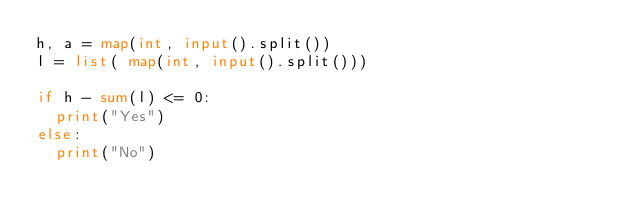<code> <loc_0><loc_0><loc_500><loc_500><_Python_>h, a = map(int, input().split())
l = list( map(int, input().split()))

if h - sum(l) <= 0:
  print("Yes")
else:
  print("No")</code> 